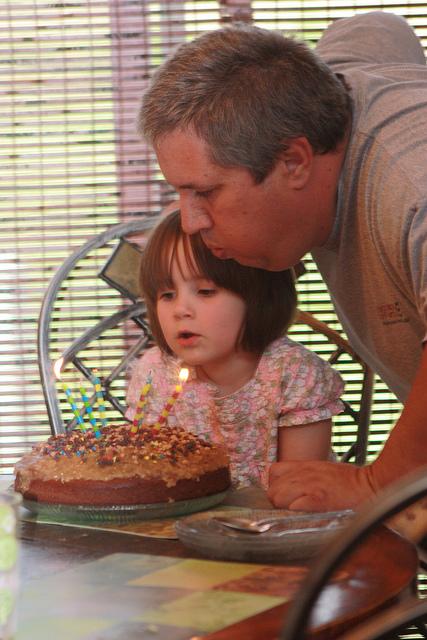What does the little girl think is special about the day?
Concise answer only. Birthday. What is the man doing?
Give a very brief answer. Blowing out candles. What is on top of the cake?
Short answer required. Candles. 